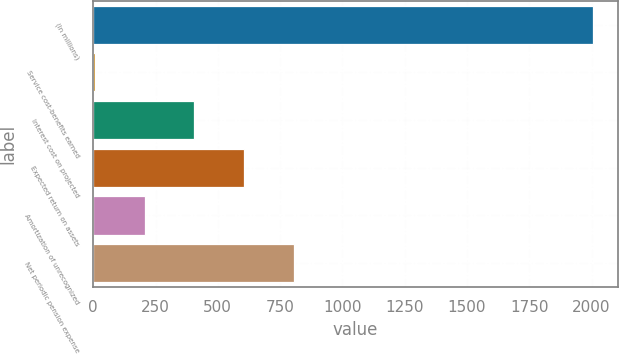Convert chart. <chart><loc_0><loc_0><loc_500><loc_500><bar_chart><fcel>(In millions)<fcel>Service cost-benefits earned<fcel>Interest cost on projected<fcel>Expected return on assets<fcel>Amortization of unrecognized<fcel>Net periodic pension expense<nl><fcel>2005<fcel>6<fcel>405.8<fcel>605.7<fcel>205.9<fcel>805.6<nl></chart> 